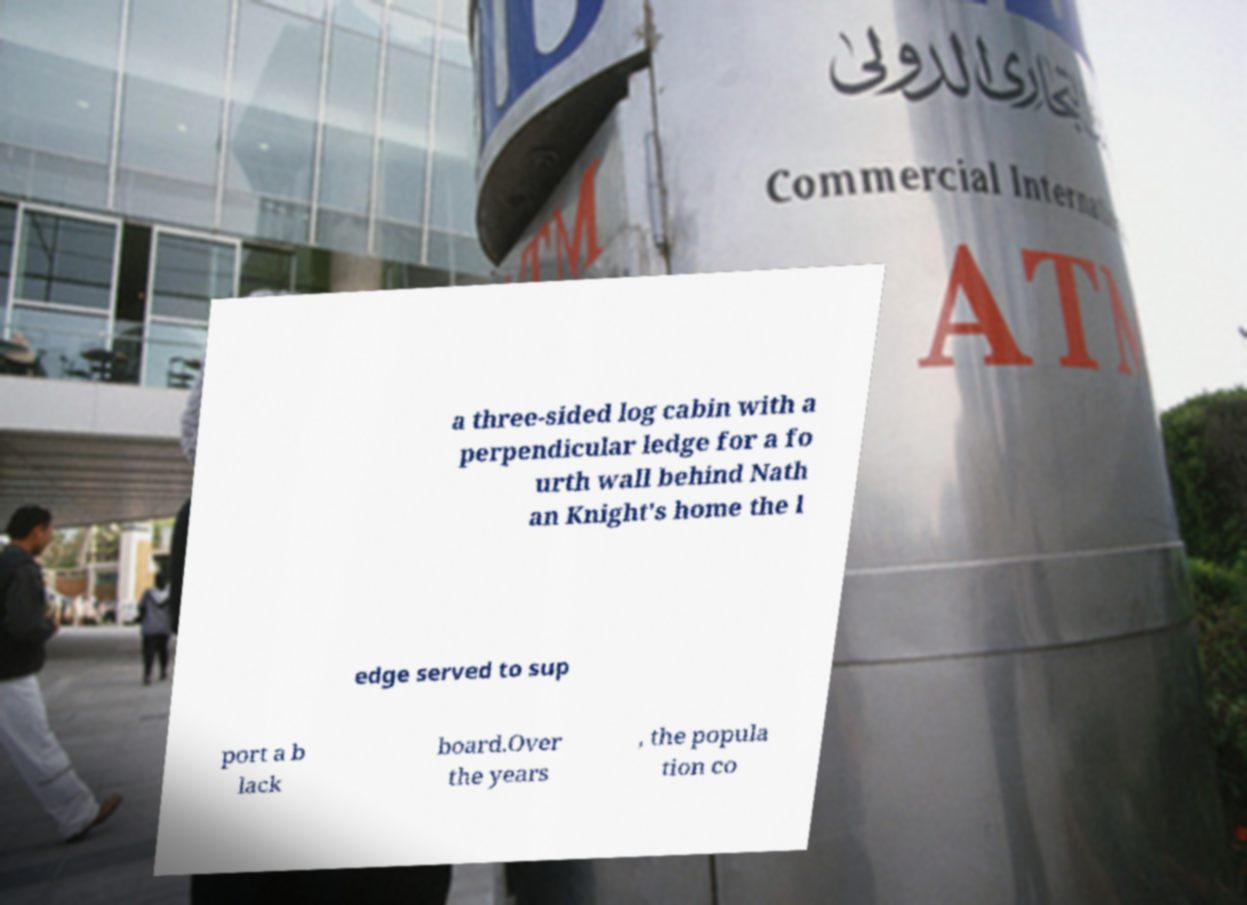For documentation purposes, I need the text within this image transcribed. Could you provide that? a three-sided log cabin with a perpendicular ledge for a fo urth wall behind Nath an Knight's home the l edge served to sup port a b lack board.Over the years , the popula tion co 